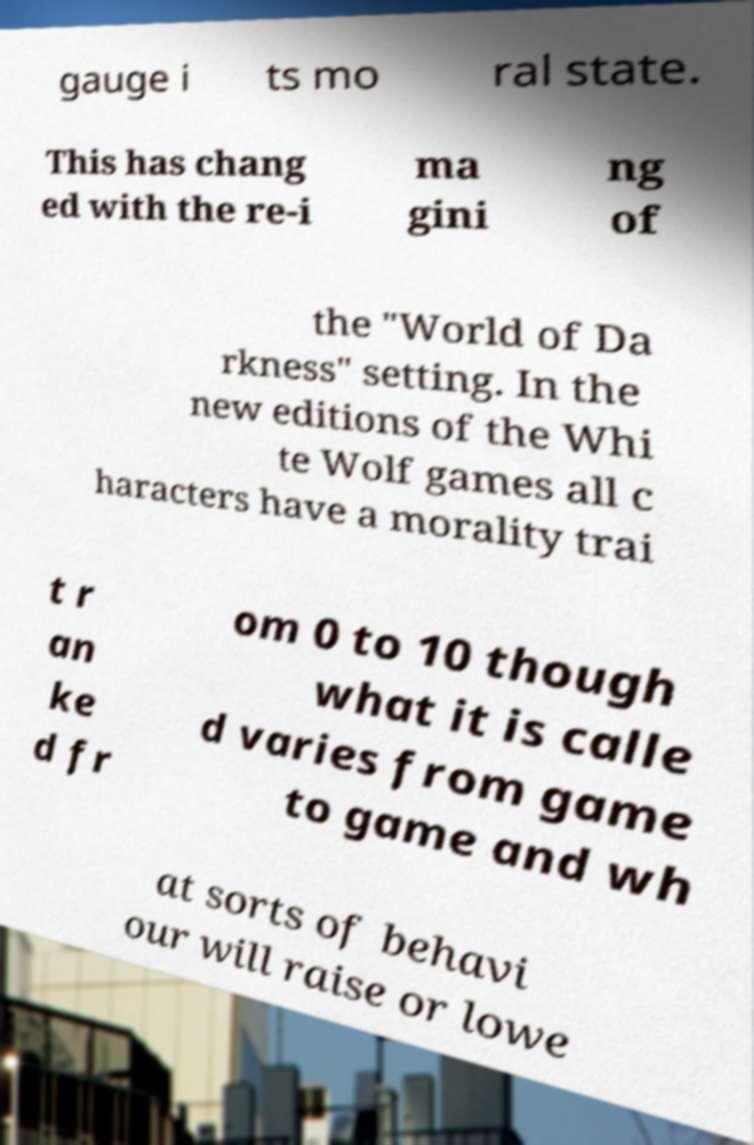Please read and relay the text visible in this image. What does it say? gauge i ts mo ral state. This has chang ed with the re-i ma gini ng of the "World of Da rkness" setting. In the new editions of the Whi te Wolf games all c haracters have a morality trai t r an ke d fr om 0 to 10 though what it is calle d varies from game to game and wh at sorts of behavi our will raise or lowe 